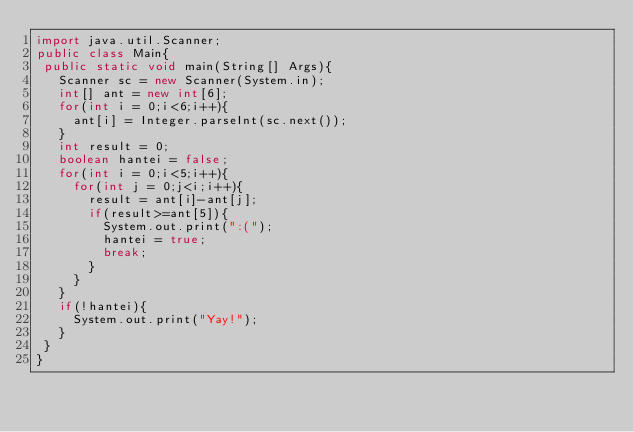Convert code to text. <code><loc_0><loc_0><loc_500><loc_500><_Java_>import java.util.Scanner;
public class Main{
 public static void main(String[] Args){
   Scanner sc = new Scanner(System.in);
   int[] ant = new int[6]; 
   for(int i = 0;i<6;i++){
     ant[i] = Integer.parseInt(sc.next());
   }
   int result = 0;
   boolean hantei = false;
   for(int i = 0;i<5;i++){
     for(int j = 0;j<i;i++){
       result = ant[i]-ant[j];
       if(result>=ant[5]){
         System.out.print(":(");
         hantei = true;
         break;
       }
     }
   }
   if(!hantei){
     System.out.print("Yay!");
   }
 }
}</code> 